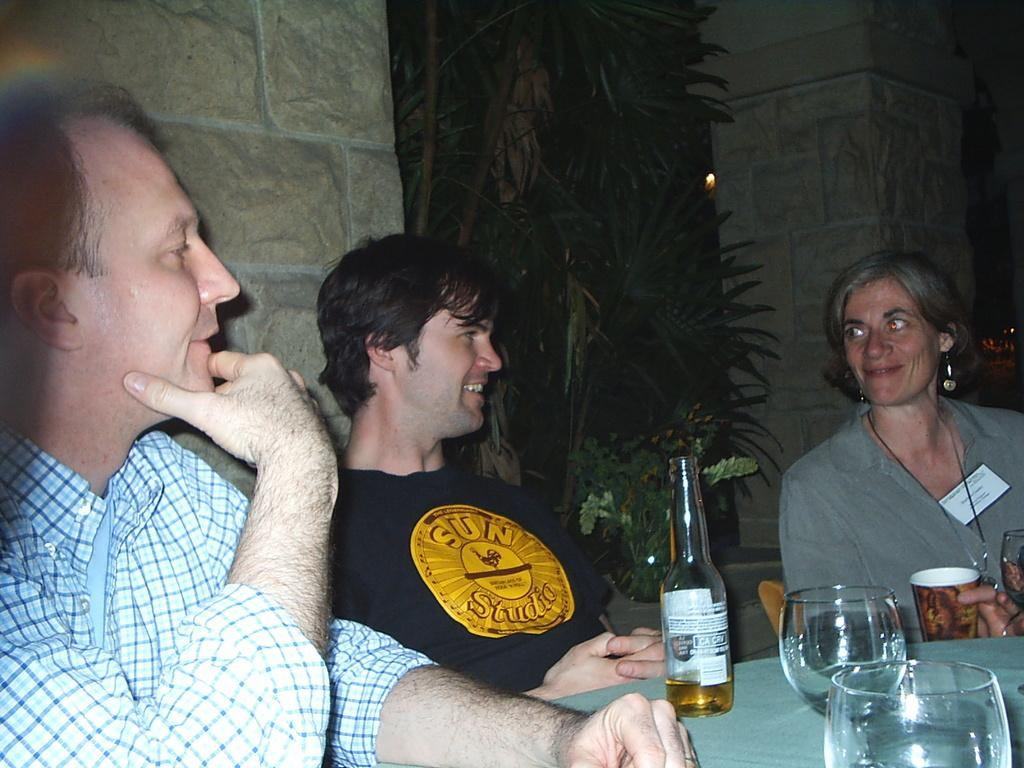How many people are in the image? There are three people in the image. What are the people doing in the image? The people are sitting on chairs. Where are the chairs located in relation to the table? The chairs are in front of a table. What items can be seen on the table? There are glasses and bottles on the table. What type of crayon is being used to draw on the table in the image? There is no crayon present in the image, and no one is drawing on the table. 